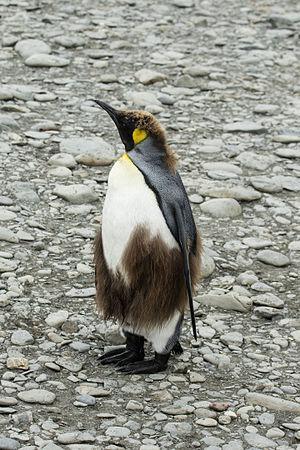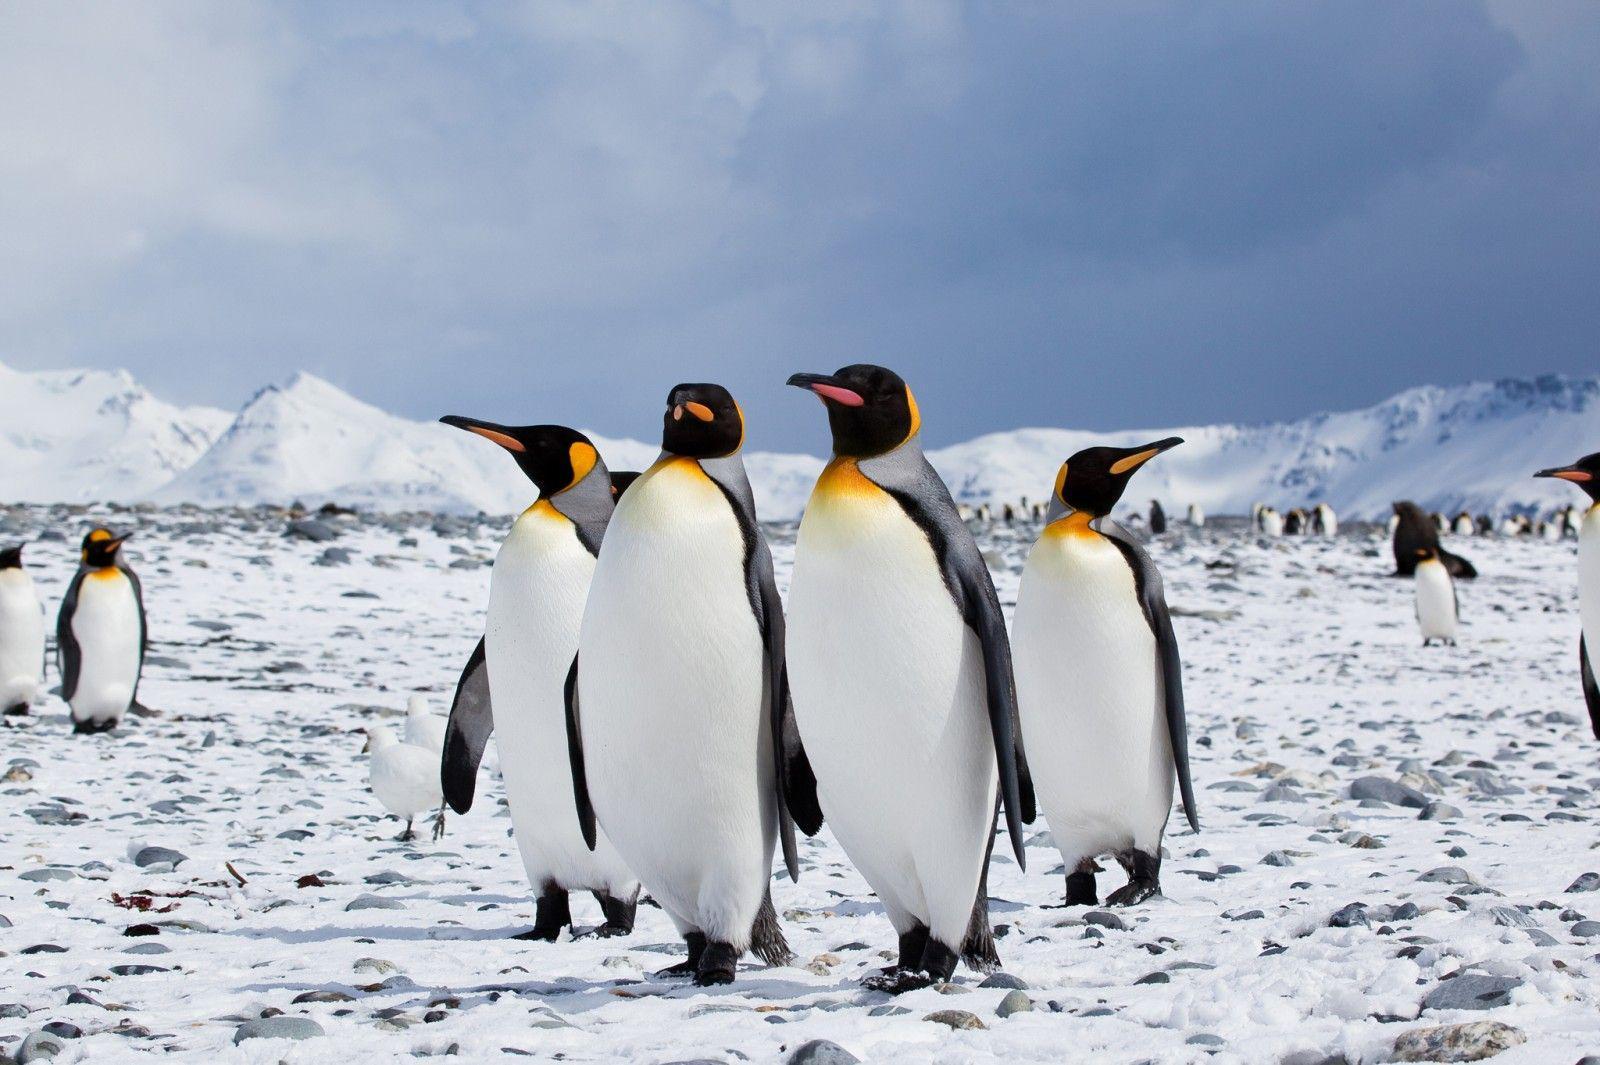The first image is the image on the left, the second image is the image on the right. For the images shown, is this caption "Atleast one picture with only one penguin." true? Answer yes or no. Yes. The first image is the image on the left, the second image is the image on the right. Given the left and right images, does the statement "One of the images includes a single penguin facing to the left." hold true? Answer yes or no. Yes. 